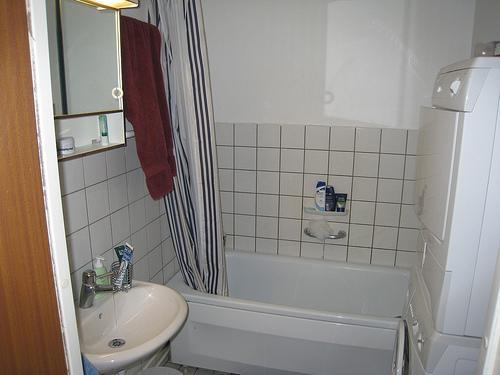How many towels are in the room?
Give a very brief answer. 1. How many sinks are in the scene?
Give a very brief answer. 1. How many mirrors are in the photo?
Give a very brief answer. 1. 